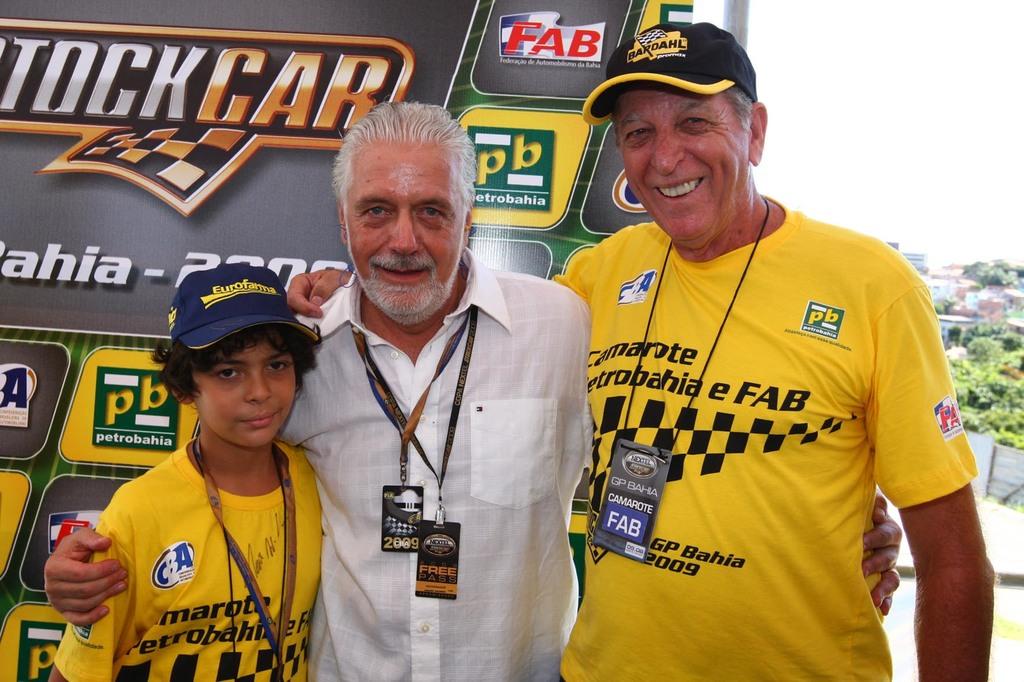What is the brand on the hat on the man on the right?
Your answer should be compact. Bardahl. What year is on the man in the middles badge?
Your answer should be compact. 2009. 